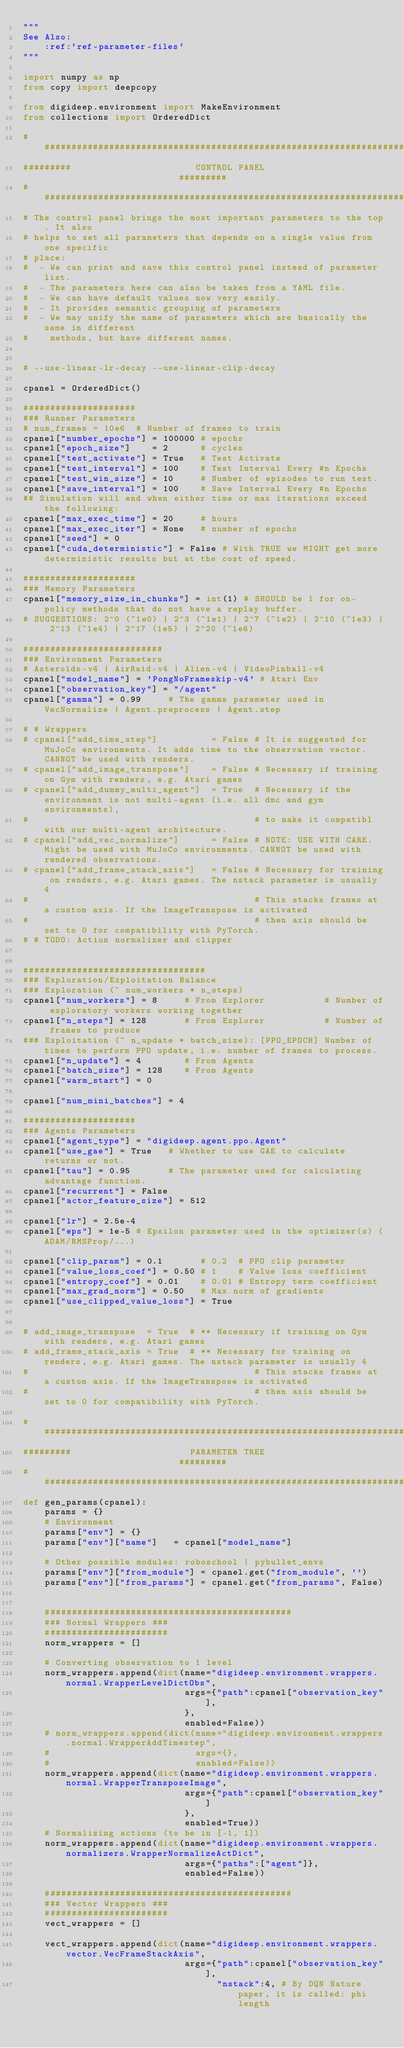Convert code to text. <code><loc_0><loc_0><loc_500><loc_500><_Python_>"""
See Also:
    :ref:`ref-parameter-files`
"""

import numpy as np
from copy import deepcopy

from digideep.environment import MakeEnvironment
from collections import OrderedDict

################################################################################
#########                       CONTROL PANEL                          #########
################################################################################
# The control panel brings the most important parameters to the top. It also
# helps to set all parameters that depends on a single value from one specific
# place:
#  - We can print and save this control panel instead of parameter list.
#  - The parameters here can also be taken from a YAML file.
#  - We can have default values now very easily.
#  - It provides semantic grouping of parameters
#  - We may unify the name of parameters which are basically the same in different
#    methods, but have different names.


# --use-linear-lr-decay --use-linear-clip-decay

cpanel = OrderedDict()

#####################
### Runner Parameters
# num_frames = 10e6  # Number of frames to train
cpanel["number_epochs"] = 100000 # epochs
cpanel["epoch_size"]    = 2      # cycles
cpanel["test_activate"] = True   # Test Activate
cpanel["test_interval"] = 100    # Test Interval Every #n Epochs
cpanel["test_win_size"] = 10     # Number of episodes to run test.
cpanel["save_interval"] = 100    # Save Interval Every #n Epochs
## Simulation will end when either time or max iterations exceed the following:
cpanel["max_exec_time"] = 20     # hours
cpanel["max_exec_iter"] = None   # number of epochs
cpanel["seed"] = 0
cpanel["cuda_deterministic"] = False # With TRUE we MIGHT get more deterministic results but at the cost of speed.

#####################
### Memory Parameters
cpanel["memory_size_in_chunks"] = int(1) # SHOULD be 1 for on-policy methods that do not have a replay buffer.
# SUGGESTIONS: 2^0 (~1e0) | 2^3 (~1e1) | 2^7 (~1e2) | 2^10 (~1e3) | 2^13 (~1e4) | 2^17 (1e5) | 2^20 (~1e6)

##########################
### Environment Parameters
# Asteroids-v4 | AirRaid-v4 | Alien-v4 | VideoPinball-v4
cpanel["model_name"] = 'PongNoFrameskip-v4' # Atari Env
cpanel["observation_key"] = "/agent"
cpanel["gamma"] = 0.99     # The gamma parameter used in VecNormalize | Agent.preprocess | Agent.step

# # Wrappers
# cpanel["add_time_step"]          = False # It is suggested for MuJoCo environments. It adds time to the observation vector. CANNOT be used with renders.
# cpanel["add_image_transpose"]    = False # Necessary if training on Gym with renders, e.g. Atari games
# cpanel["add_dummy_multi_agent"]  = True  # Necessary if the environment is not multi-agent (i.e. all dmc and gym environments),
#                                          # to make it compatibl with our multi-agent architecture.
# cpanel["add_vec_normalize"]      = False # NOTE: USE WITH CARE. Might be used with MuJoCo environments. CANNOT be used with rendered observations.
# cpanel["add_frame_stack_axis"]   = False # Necessary for training on renders, e.g. Atari games. The nstack parameter is usually 4
#                                          # This stacks frames at a custom axis. If the ImageTranspose is activated
#                                          # then axis should be set to 0 for compatibility with PyTorch.
# # TODO: Action normalizer and clipper


##################################
### Exploration/Exploitation Balance
### Exploration (~ num_workers * n_steps)
cpanel["num_workers"] = 8     # From Explorer           # Number of exploratory workers working together
cpanel["n_steps"] = 128       # From Explorer           # Number of frames to produce
### Exploitation (~ n_update * batch_size): [PPO_EPOCH] Number of times to perform PPO update, i.e. number of frames to process.
cpanel["n_update"] = 4        # From Agents
cpanel["batch_size"] = 128    # From Agents
cpanel["warm_start"] = 0

cpanel["num_mini_batches"] = 4

#####################
### Agents Parameters
cpanel["agent_type"] = "digideep.agent.ppo.Agent"
cpanel["use_gae"] = True   # Whether to use GAE to calculate returns or not.
cpanel["tau"] = 0.95       # The parameter used for calculating advantage function.
cpanel["recurrent"] = False
cpanel["actor_feature_size"] = 512

cpanel["lr"] = 2.5e-4
cpanel["eps"] = 1e-5 # Epsilon parameter used in the optimizer(s) (ADAM/RMSProp/...)

cpanel["clip_param"] = 0.1       # 0.2  # PPO clip parameter
cpanel["value_loss_coef"] = 0.50 # 1    # Value loss coefficient
cpanel["entropy_coef"] = 0.01    # 0.01 # Entropy term coefficient
cpanel["max_grad_norm"] = 0.50   # Max norm of gradients
cpanel["use_clipped_value_loss"] = True


# add_image_transpose  = True  # ** Necessary if training on Gym with renders, e.g. Atari games
# add_frame_stack_axis = True  # ** Necessary for training on renders, e.g. Atari games. The nstack parameter is usually 4
#                                          # This stacks frames at a custom axis. If the ImageTranspose is activated
#                                          # then axis should be set to 0 for compatibility with PyTorch.

################################################################################
#########                      PARAMETER TREE                          #########
################################################################################
def gen_params(cpanel):
    params = {}
    # Environment
    params["env"] = {}
    params["env"]["name"]   = cpanel["model_name"]

    # Other possible modules: roboschool | pybullet_envs
    params["env"]["from_module"] = cpanel.get("from_module", '')
    params["env"]["from_params"] = cpanel.get("from_params", False)

    
    ##############################################
    ### Normal Wrappers ###
    #######################
    norm_wrappers = []

    # Converting observation to 1 level
    norm_wrappers.append(dict(name="digideep.environment.wrappers.normal.WrapperLevelDictObs",
                              args={"path":cpanel["observation_key"],
                              },
                              enabled=False))
    # norm_wrappers.append(dict(name="digideep.environment.wrappers.normal.WrapperAddTimestep",
    #                           args={},
    #                           enabled=False))
    norm_wrappers.append(dict(name="digideep.environment.wrappers.normal.WrapperTransposeImage",
                              args={"path":cpanel["observation_key"]
                              },
                              enabled=True))
    # Normalizing actions (to be in [-1, 1])
    norm_wrappers.append(dict(name="digideep.environment.wrappers.normalizers.WrapperNormalizeActDict",
                              args={"paths":["agent"]},
                              enabled=False))

    ##############################################
    ### Vector Wrappers ###
    #######################
    vect_wrappers = []

    vect_wrappers.append(dict(name="digideep.environment.wrappers.vector.VecFrameStackAxis",
                              args={"path":cpanel["observation_key"],
                                    "nstack":4, # By DQN Nature paper, it is called: phi length</code> 